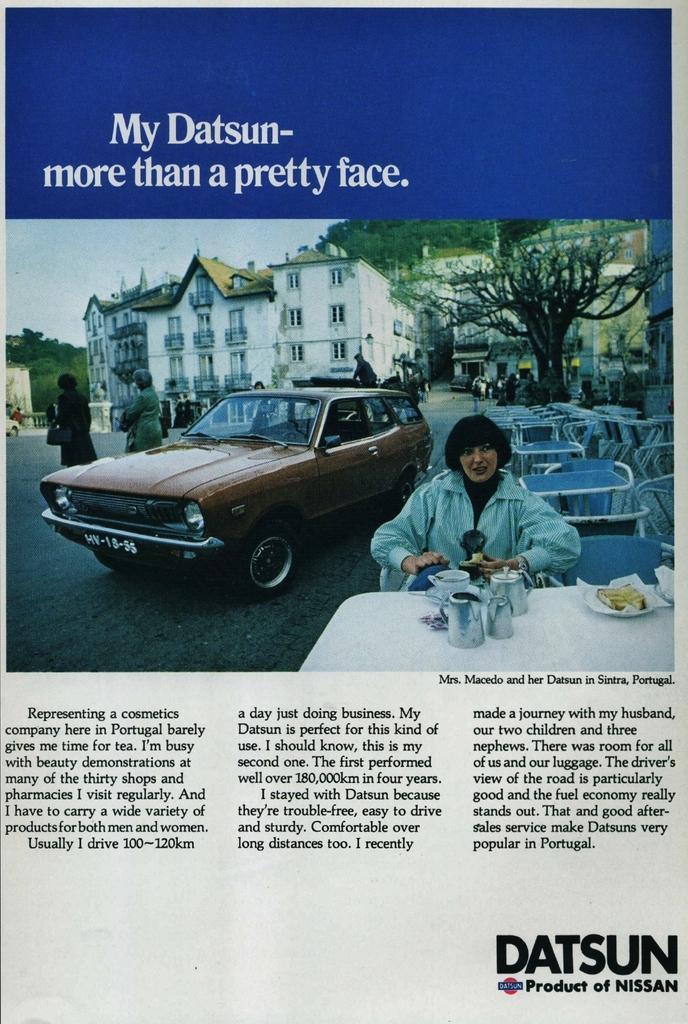What type of visual representation is the image? The image is a poster. What type of furniture is visible in the image? There are chairs and tables in the image. Are there any people present in the image? Yes, there are persons in the image. What type of containers are visible in the image? There are jugs in the image. What type of transportation is visible in the image? There are vehicles in the image. What type of consumable items are visible in the image? There are food items in the image. What type of pathway is visible in the image? There is a road in the image. What type of natural vegetation is visible in the image? There are trees in the image. What part of the natural environment is visible in the image? The sky is visible in the image. Reasoning: Let's think step by breaking down the image into its main components. We start by identifying the type of visual representation, which is a poster. Then, we describe the various objects and elements present in the image, such as furniture, people, containers, transportation, consumable items, pathways, vegetation, and the sky. Each question is designed to elicit a specific detail about the image that is known from the provided facts. Absurd Question/Answer: How does the digestion process of the food items in the image work? The image does not show the digestion process of the food items; it only depicts them as visual elements. What type of footwear are the persons in the image wearing on their toes? The image does not show the footwear of the persons; it only depicts them as visual elements. What type of weather can be seen in the image? The image does not depict any weather conditions; it only shows the various objects and elements present in the scene. 